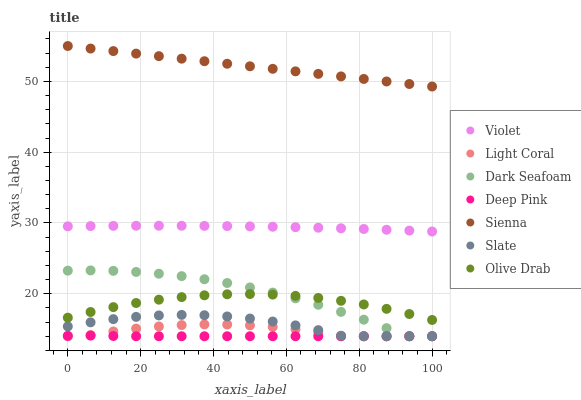Does Deep Pink have the minimum area under the curve?
Answer yes or no. Yes. Does Sienna have the maximum area under the curve?
Answer yes or no. Yes. Does Slate have the minimum area under the curve?
Answer yes or no. No. Does Slate have the maximum area under the curve?
Answer yes or no. No. Is Sienna the smoothest?
Answer yes or no. Yes. Is Dark Seafoam the roughest?
Answer yes or no. Yes. Is Deep Pink the smoothest?
Answer yes or no. No. Is Deep Pink the roughest?
Answer yes or no. No. Does Deep Pink have the lowest value?
Answer yes or no. Yes. Does Violet have the lowest value?
Answer yes or no. No. Does Sienna have the highest value?
Answer yes or no. Yes. Does Slate have the highest value?
Answer yes or no. No. Is Deep Pink less than Violet?
Answer yes or no. Yes. Is Violet greater than Olive Drab?
Answer yes or no. Yes. Does Dark Seafoam intersect Deep Pink?
Answer yes or no. Yes. Is Dark Seafoam less than Deep Pink?
Answer yes or no. No. Is Dark Seafoam greater than Deep Pink?
Answer yes or no. No. Does Deep Pink intersect Violet?
Answer yes or no. No. 